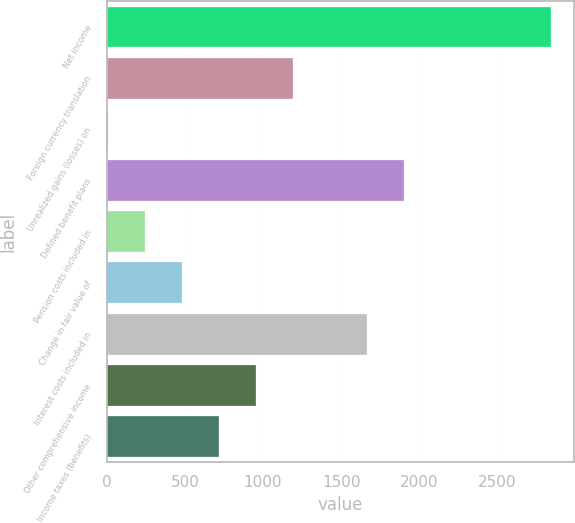Convert chart. <chart><loc_0><loc_0><loc_500><loc_500><bar_chart><fcel>Net income<fcel>Foreign currency translation<fcel>Unrealized gains (losses) on<fcel>Defined benefit plans<fcel>Pension costs included in<fcel>Change in fair value of<fcel>Interest costs included in<fcel>Other comprehensive income<fcel>Income taxes (benefits)<nl><fcel>2845.8<fcel>1191<fcel>9<fcel>1900.2<fcel>245.4<fcel>481.8<fcel>1663.8<fcel>954.6<fcel>718.2<nl></chart> 